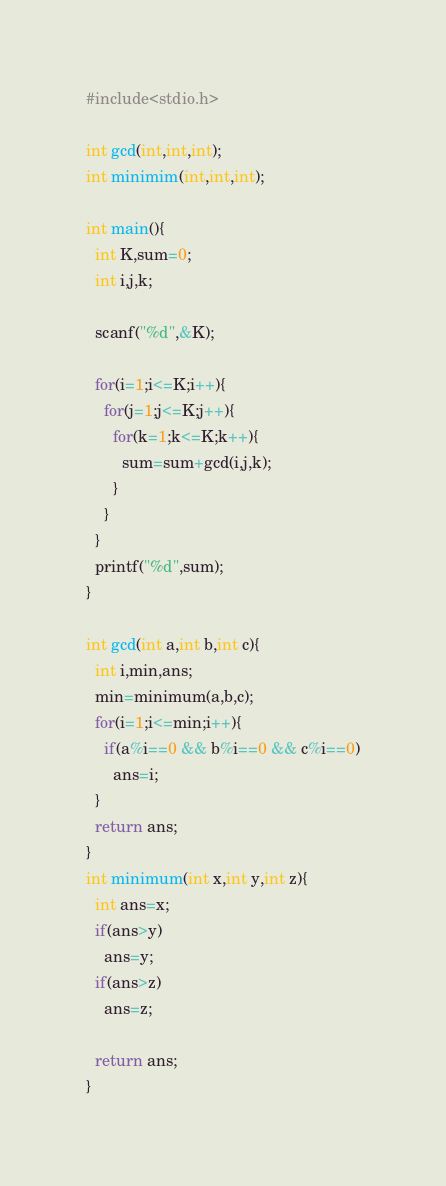<code> <loc_0><loc_0><loc_500><loc_500><_C_>#include<stdio.h>

int gcd(int,int,int);
int minimim(int,int,int);

int main(){
  int K,sum=0;
  int i,j,k;
  
  scanf("%d",&K);
  
  for(i=1;i<=K;i++){
    for(j=1;j<=K;j++){
      for(k=1;k<=K;k++){
        sum=sum+gcd(i,j,k);
      }
    }
  }
  printf("%d",sum);
}

int gcd(int a,int b,int c){
  int i,min,ans;
  min=minimum(a,b,c);
  for(i=1;i<=min;i++){
    if(a%i==0 && b%i==0 && c%i==0)
      ans=i;
  }
  return ans;
}
int minimum(int x,int y,int z){
  int ans=x;
  if(ans>y)
    ans=y;
  if(ans>z)
    ans=z;
  
  return ans;
}</code> 